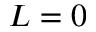Convert formula to latex. <formula><loc_0><loc_0><loc_500><loc_500>L = 0</formula> 